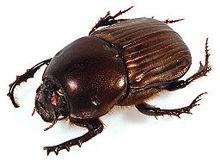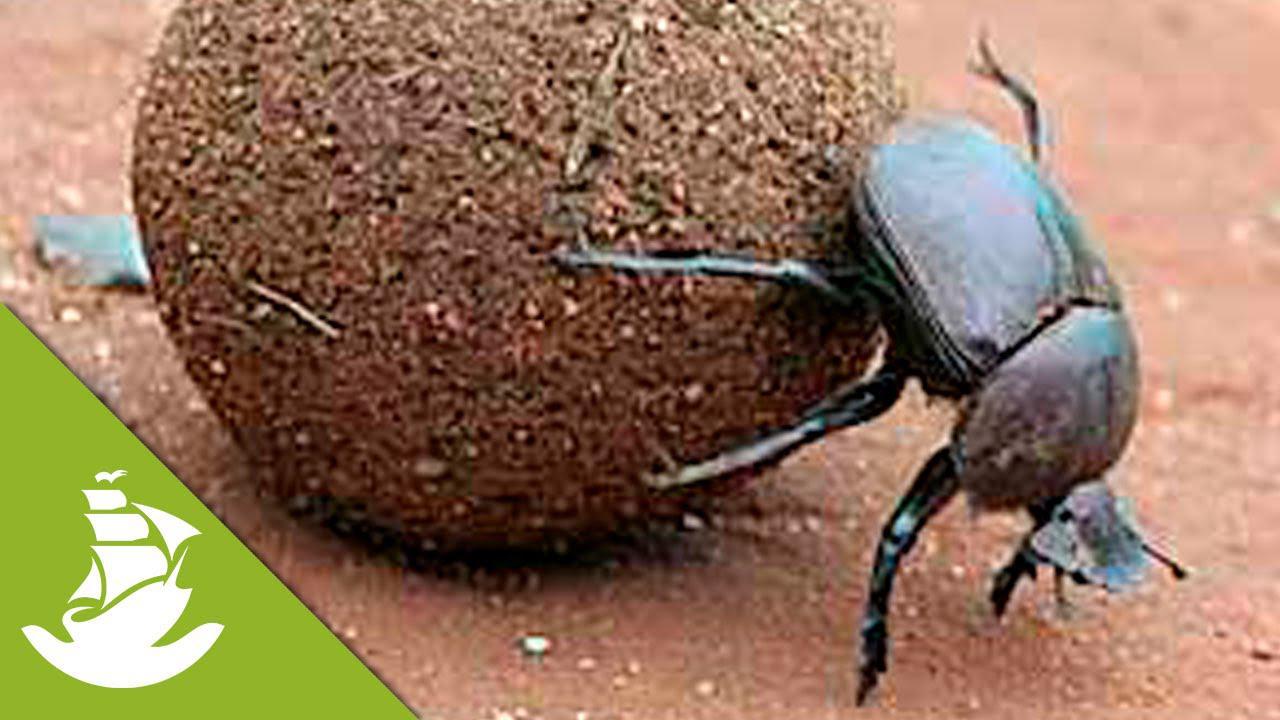The first image is the image on the left, the second image is the image on the right. For the images shown, is this caption "A beetle is perched on a ball with its front legs touching the ground on the right side of the image." true? Answer yes or no. Yes. The first image is the image on the left, the second image is the image on the right. Given the left and right images, does the statement "One beetle sits on the top of the clod of dirt in the image on the left." hold true? Answer yes or no. No. 